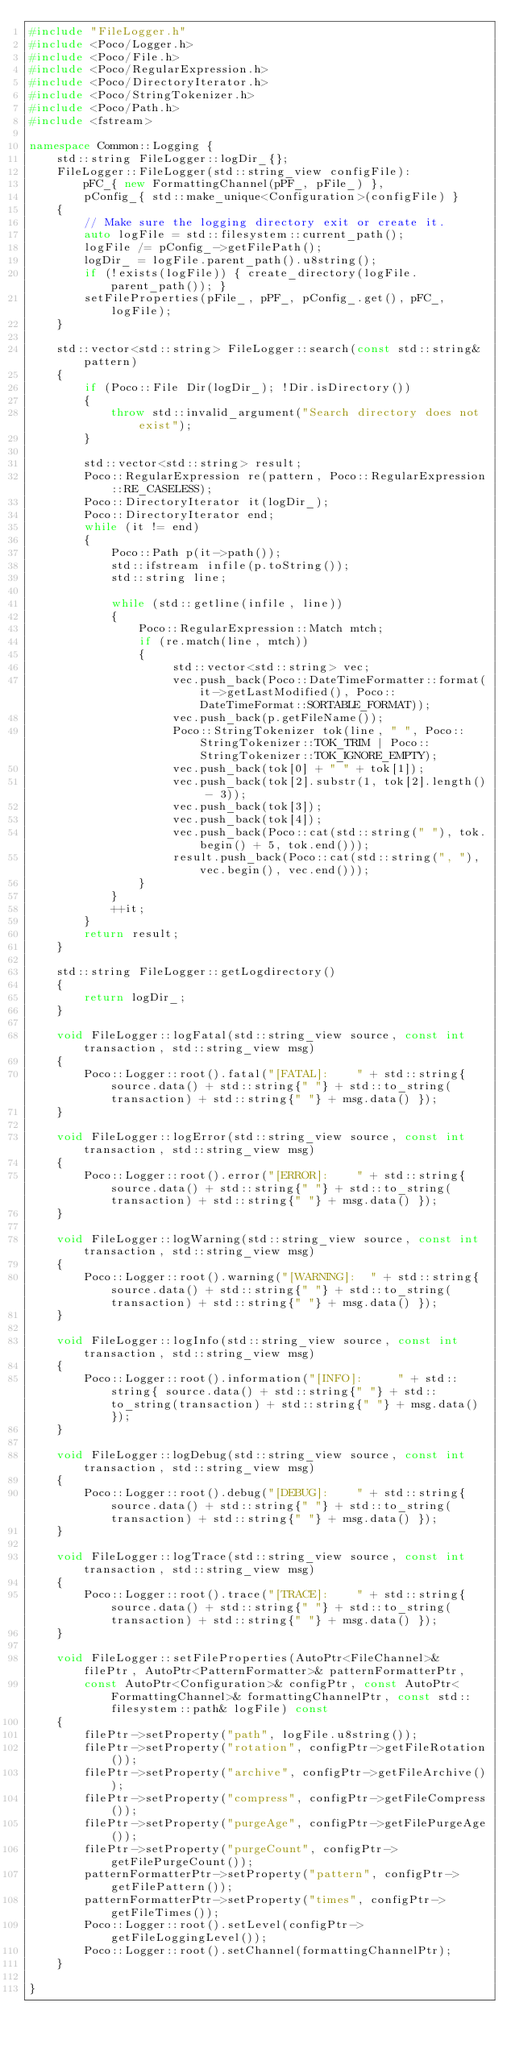Convert code to text. <code><loc_0><loc_0><loc_500><loc_500><_C++_>#include "FileLogger.h"
#include <Poco/Logger.h>
#include <Poco/File.h>
#include <Poco/RegularExpression.h>
#include <Poco/DirectoryIterator.h>
#include <Poco/StringTokenizer.h>
#include <Poco/Path.h>
#include <fstream>

namespace Common::Logging {
    std::string FileLogger::logDir_{};
    FileLogger::FileLogger(std::string_view configFile):
        pFC_{ new FormattingChannel(pPF_, pFile_) },
        pConfig_{ std::make_unique<Configuration>(configFile) }
    {
        // Make sure the logging directory exit or create it.
        auto logFile = std::filesystem::current_path();
        logFile /= pConfig_->getFilePath();
        logDir_ = logFile.parent_path().u8string();
        if (!exists(logFile)) { create_directory(logFile.parent_path()); }
        setFileProperties(pFile_, pPF_, pConfig_.get(), pFC_, logFile);
    }

    std::vector<std::string> FileLogger::search(const std::string& pattern)
    {
        if (Poco::File Dir(logDir_); !Dir.isDirectory())
        {
            throw std::invalid_argument("Search directory does not exist");
        }

        std::vector<std::string> result;
        Poco::RegularExpression re(pattern, Poco::RegularExpression::RE_CASELESS);
        Poco::DirectoryIterator it(logDir_);
        Poco::DirectoryIterator end;
        while (it != end)
        {
            Poco::Path p(it->path());
            std::ifstream infile(p.toString());
            std::string line;

            while (std::getline(infile, line))
            {
                Poco::RegularExpression::Match mtch;
                if (re.match(line, mtch))
                {
                     std::vector<std::string> vec;
                     vec.push_back(Poco::DateTimeFormatter::format(it->getLastModified(), Poco::DateTimeFormat::SORTABLE_FORMAT));
                     vec.push_back(p.getFileName());
                     Poco::StringTokenizer tok(line, " ", Poco::StringTokenizer::TOK_TRIM | Poco::StringTokenizer::TOK_IGNORE_EMPTY);
                     vec.push_back(tok[0] + " " + tok[1]);
                     vec.push_back(tok[2].substr(1, tok[2].length() - 3));
                     vec.push_back(tok[3]);
                     vec.push_back(tok[4]);
                     vec.push_back(Poco::cat(std::string(" "), tok.begin() + 5, tok.end()));
                     result.push_back(Poco::cat(std::string(", "), vec.begin(), vec.end()));
                }
            }
            ++it;
        }
        return result;
    }

    std::string FileLogger::getLogdirectory()
    {
        return logDir_;
    }

	void FileLogger::logFatal(std::string_view source, const int transaction, std::string_view msg)
    {
        Poco::Logger::root().fatal("[FATAL]:    " + std::string{ source.data() + std::string{" "} + std::to_string(transaction) + std::string{" "} + msg.data() });
    }

    void FileLogger::logError(std::string_view source, const int transaction, std::string_view msg)
    {
        Poco::Logger::root().error("[ERROR]:    " + std::string{ source.data() + std::string{" "} + std::to_string(transaction) + std::string{" "} + msg.data() });
    }

    void FileLogger::logWarning(std::string_view source, const int transaction, std::string_view msg)
    {
        Poco::Logger::root().warning("[WARNING]:  " + std::string{ source.data() + std::string{" "} + std::to_string(transaction) + std::string{" "} + msg.data() });
    }

    void FileLogger::logInfo(std::string_view source, const int transaction, std::string_view msg)
    {
        Poco::Logger::root().information("[INFO]:     " + std::string{ source.data() + std::string{" "} + std::to_string(transaction) + std::string{" "} + msg.data() });
    }

    void FileLogger::logDebug(std::string_view source, const int transaction, std::string_view msg)
    {
        Poco::Logger::root().debug("[DEBUG]:    " + std::string{ source.data() + std::string{" "} + std::to_string(transaction) + std::string{" "} + msg.data() });
    }

    void FileLogger::logTrace(std::string_view source, const int transaction, std::string_view msg)
    {
        Poco::Logger::root().trace("[TRACE]:    " + std::string{ source.data() + std::string{" "} + std::to_string(transaction) + std::string{" "} + msg.data() });
    }

    void FileLogger::setFileProperties(AutoPtr<FileChannel>& filePtr, AutoPtr<PatternFormatter>& patternFormatterPtr,
        const AutoPtr<Configuration>& configPtr, const AutoPtr<FormattingChannel>& formattingChannelPtr, const std::filesystem::path& logFile) const
    {
        filePtr->setProperty("path", logFile.u8string());
        filePtr->setProperty("rotation", configPtr->getFileRotation());
        filePtr->setProperty("archive", configPtr->getFileArchive());
        filePtr->setProperty("compress", configPtr->getFileCompress());
        filePtr->setProperty("purgeAge", configPtr->getFilePurgeAge());
        filePtr->setProperty("purgeCount", configPtr->getFilePurgeCount());
        patternFormatterPtr->setProperty("pattern", configPtr->getFilePattern());
        patternFormatterPtr->setProperty("times", configPtr->getFileTimes());
        Poco::Logger::root().setLevel(configPtr->getFileLoggingLevel());
        Poco::Logger::root().setChannel(formattingChannelPtr);
    }

}
</code> 